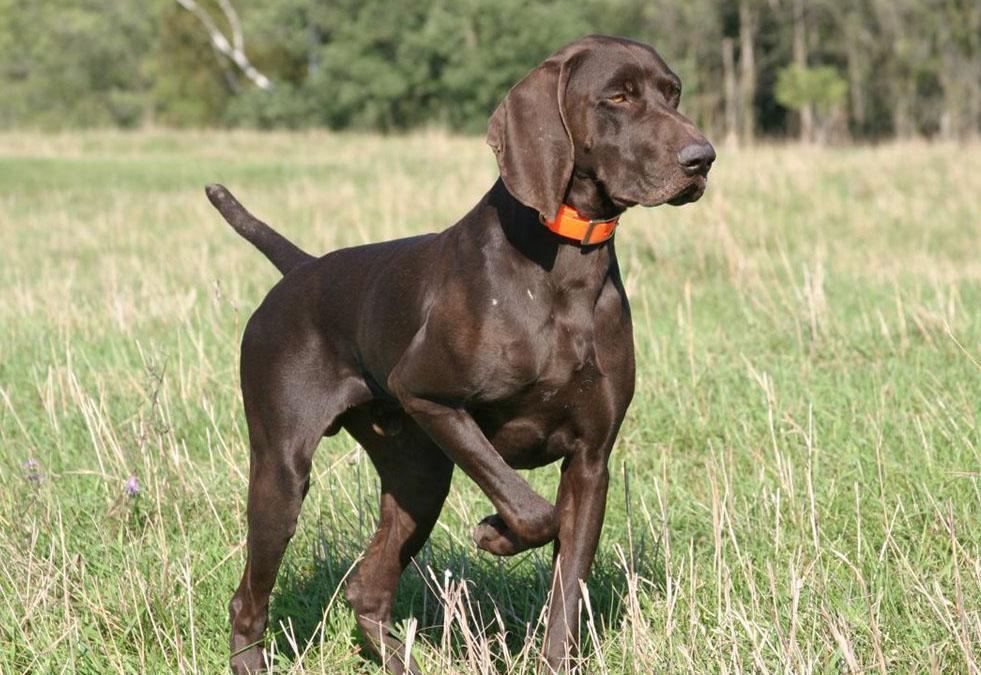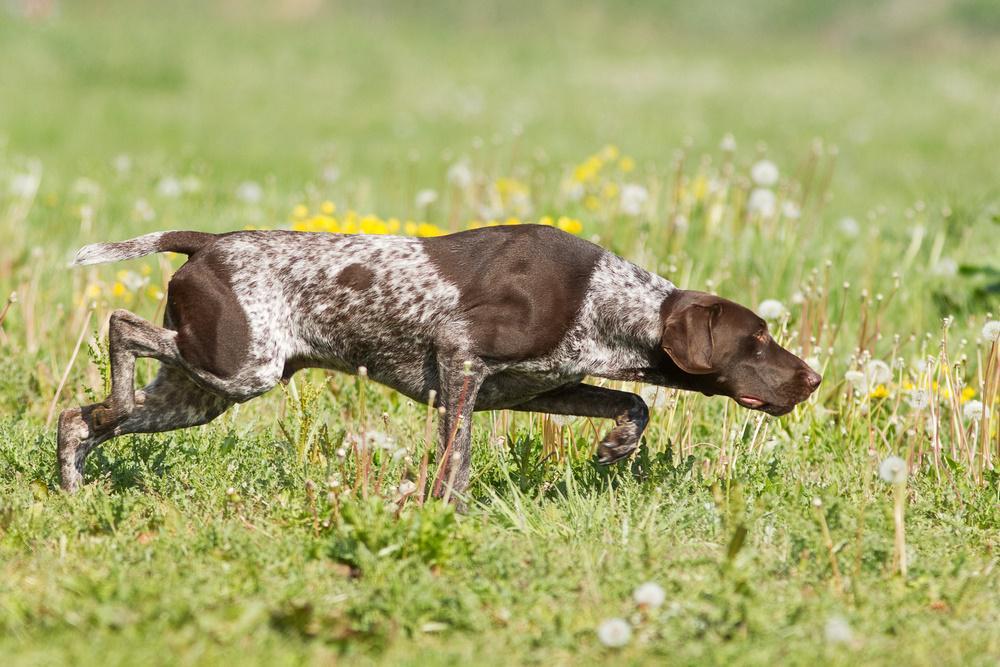The first image is the image on the left, the second image is the image on the right. Examine the images to the left and right. Is the description "In one of the images, there is a dog wearing an orange collar." accurate? Answer yes or no. Yes. The first image is the image on the left, the second image is the image on the right. Assess this claim about the two images: "The dogs in both images are wearing collars.". Correct or not? Answer yes or no. No. 